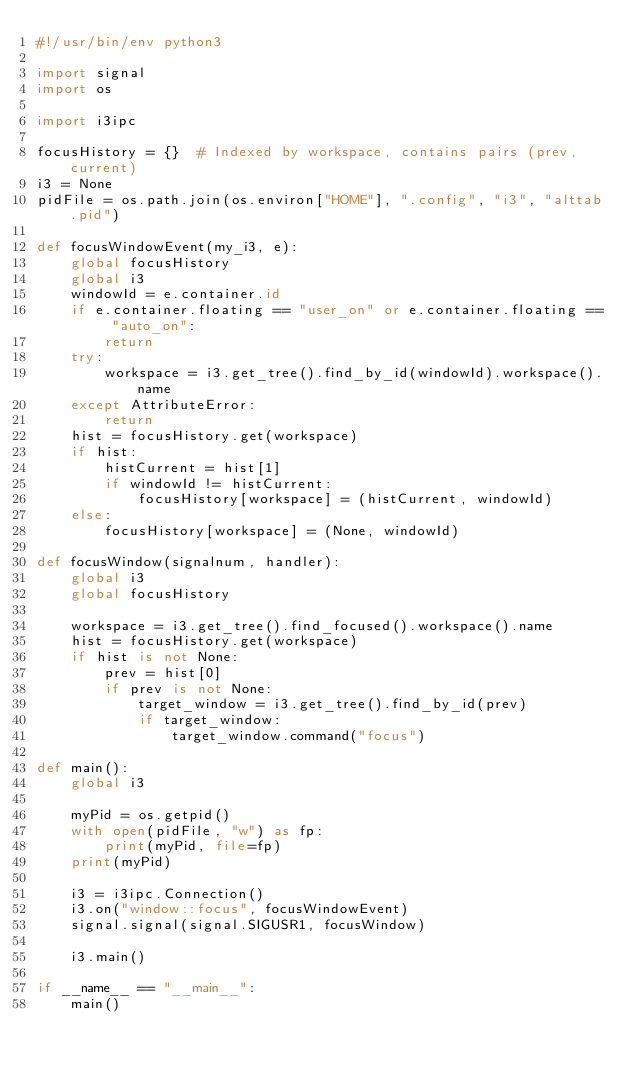<code> <loc_0><loc_0><loc_500><loc_500><_Python_>#!/usr/bin/env python3

import signal
import os

import i3ipc

focusHistory = {}  # Indexed by workspace, contains pairs (prev, current)
i3 = None
pidFile = os.path.join(os.environ["HOME"], ".config", "i3", "alttab.pid")

def focusWindowEvent(my_i3, e):
    global focusHistory
    global i3
    windowId = e.container.id
    if e.container.floating == "user_on" or e.container.floating == "auto_on":
        return
    try:
        workspace = i3.get_tree().find_by_id(windowId).workspace().name
    except AttributeError:
        return
    hist = focusHistory.get(workspace)
    if hist:
        histCurrent = hist[1]
        if windowId != histCurrent:
            focusHistory[workspace] = (histCurrent, windowId)
    else:
        focusHistory[workspace] = (None, windowId)

def focusWindow(signalnum, handler):
    global i3
    global focusHistory

    workspace = i3.get_tree().find_focused().workspace().name
    hist = focusHistory.get(workspace)
    if hist is not None:
        prev = hist[0]
        if prev is not None:
            target_window = i3.get_tree().find_by_id(prev)
            if target_window:
                target_window.command("focus")

def main():
    global i3

    myPid = os.getpid()
    with open(pidFile, "w") as fp:
        print(myPid, file=fp)
    print(myPid)

    i3 = i3ipc.Connection()
    i3.on("window::focus", focusWindowEvent)
    signal.signal(signal.SIGUSR1, focusWindow)

    i3.main()

if __name__ == "__main__":
    main()
</code> 